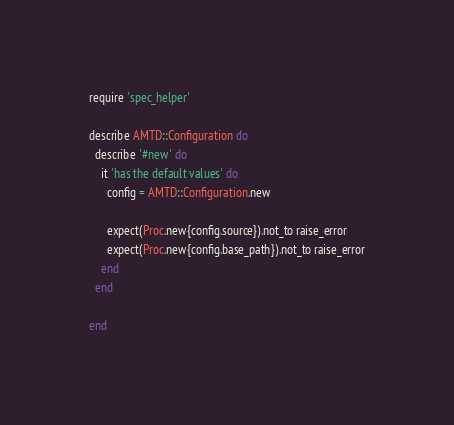Convert code to text. <code><loc_0><loc_0><loc_500><loc_500><_Ruby_>require 'spec_helper'

describe AMTD::Configuration do
  describe '#new' do
    it 'has the default values' do
      config = AMTD::Configuration.new

      expect(Proc.new{config.source}).not_to raise_error
      expect(Proc.new{config.base_path}).not_to raise_error
    end
  end

end
</code> 